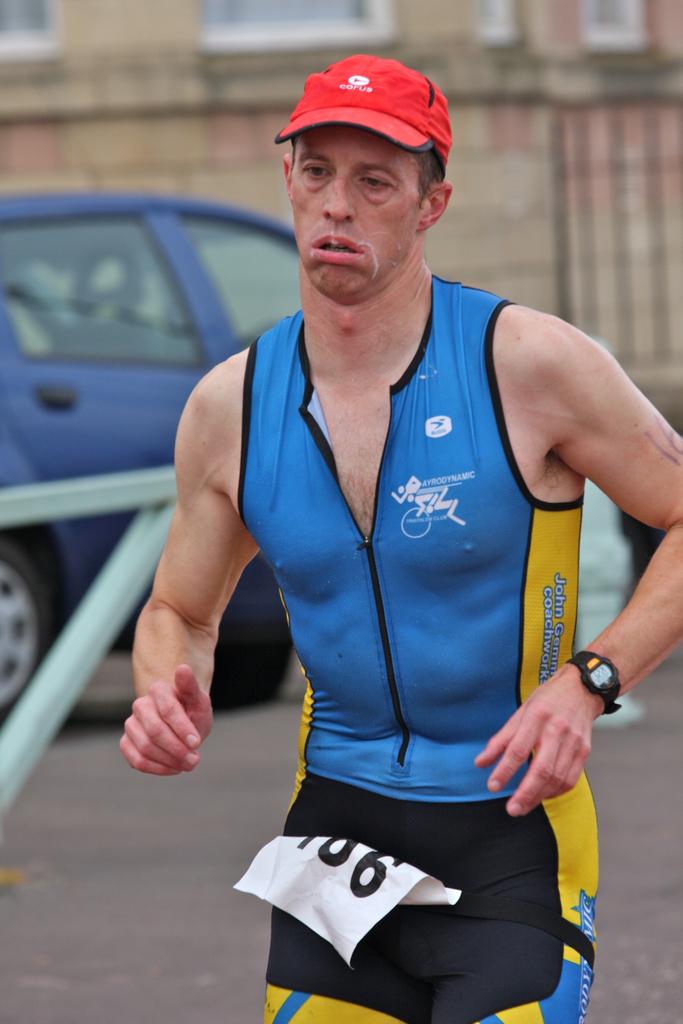What male first name is written on this man's side?
Give a very brief answer. John. 